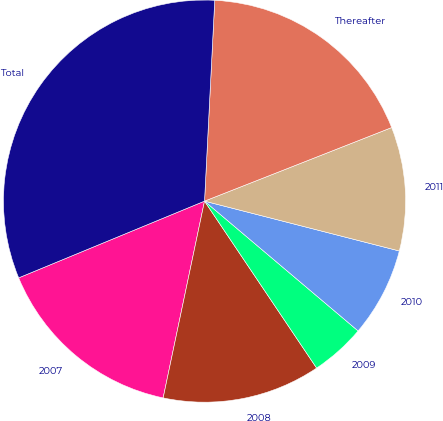<chart> <loc_0><loc_0><loc_500><loc_500><pie_chart><fcel>2007<fcel>2008<fcel>2009<fcel>2010<fcel>2011<fcel>Thereafter<fcel>Total<nl><fcel>15.47%<fcel>12.71%<fcel>4.42%<fcel>7.18%<fcel>9.95%<fcel>18.23%<fcel>32.04%<nl></chart> 